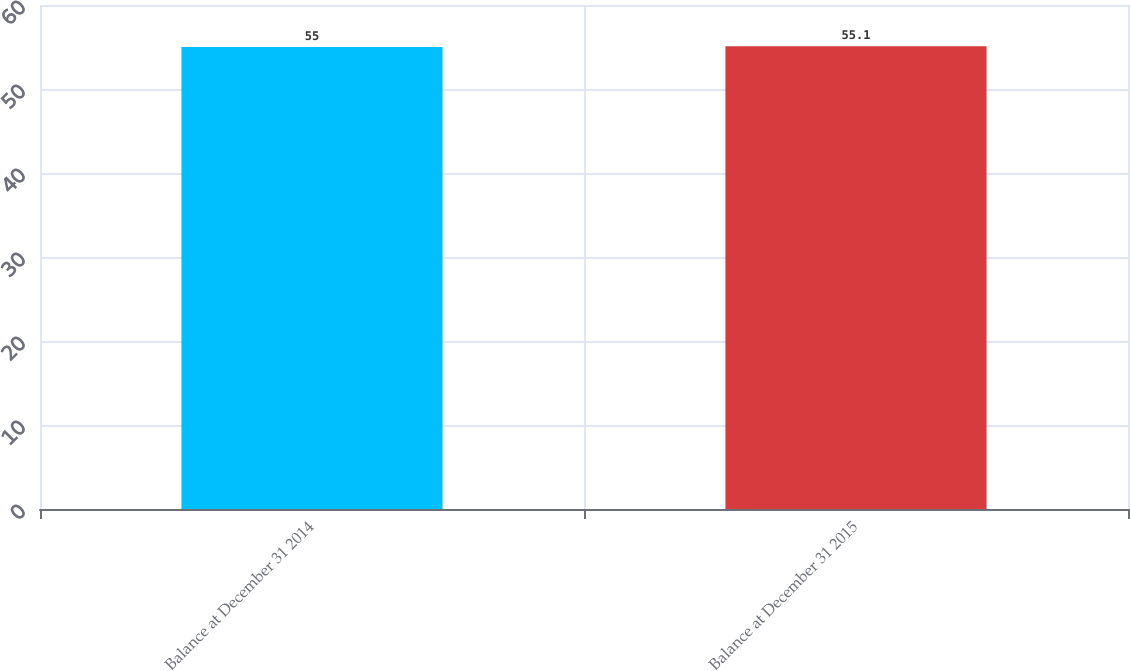<chart> <loc_0><loc_0><loc_500><loc_500><bar_chart><fcel>Balance at December 31 2014<fcel>Balance at December 31 2015<nl><fcel>55<fcel>55.1<nl></chart> 